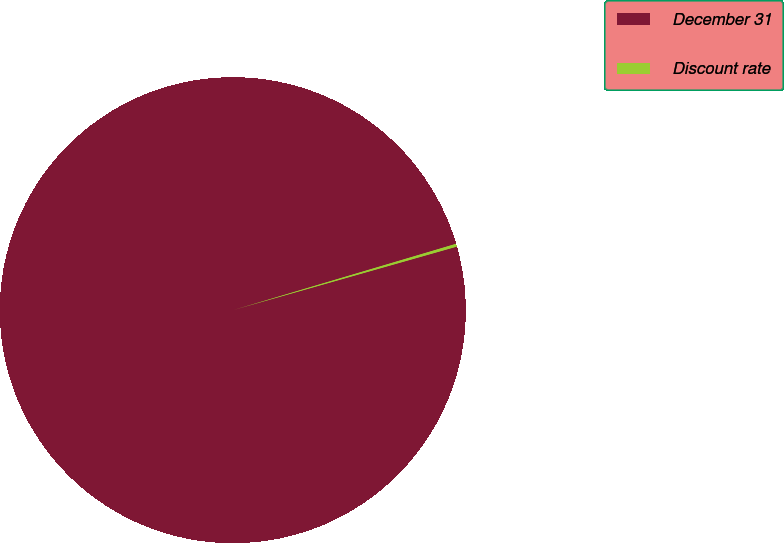<chart> <loc_0><loc_0><loc_500><loc_500><pie_chart><fcel>December 31<fcel>Discount rate<nl><fcel>99.8%<fcel>0.2%<nl></chart> 